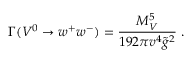Convert formula to latex. <formula><loc_0><loc_0><loc_500><loc_500>\Gamma ( V ^ { 0 } \to w ^ { + } w ^ { - } ) = { \frac { M _ { V } ^ { 5 } } { 1 9 2 \pi v ^ { 4 } \tilde { g } ^ { 2 } } } \, .</formula> 